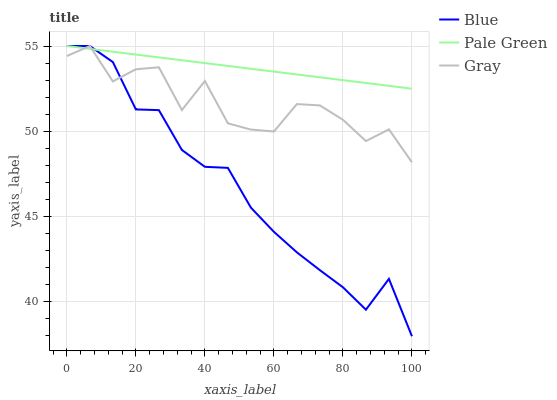Does Gray have the minimum area under the curve?
Answer yes or no. No. Does Gray have the maximum area under the curve?
Answer yes or no. No. Is Gray the smoothest?
Answer yes or no. No. Is Pale Green the roughest?
Answer yes or no. No. Does Gray have the lowest value?
Answer yes or no. No. 